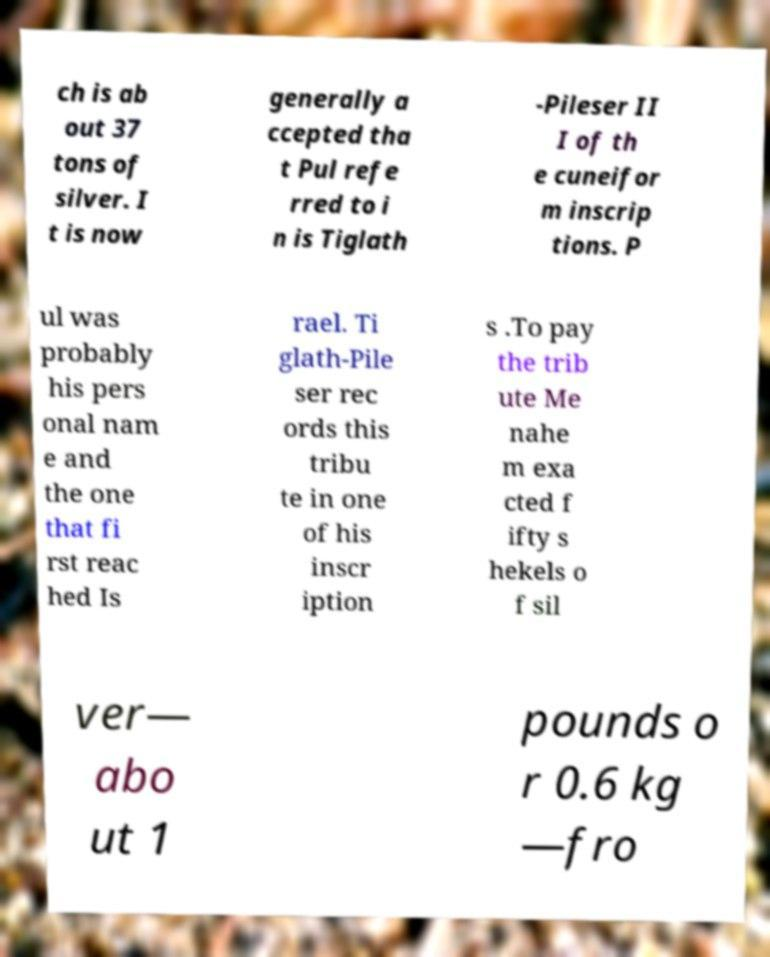There's text embedded in this image that I need extracted. Can you transcribe it verbatim? ch is ab out 37 tons of silver. I t is now generally a ccepted tha t Pul refe rred to i n is Tiglath -Pileser II I of th e cuneifor m inscrip tions. P ul was probably his pers onal nam e and the one that fi rst reac hed Is rael. Ti glath-Pile ser rec ords this tribu te in one of his inscr iption s .To pay the trib ute Me nahe m exa cted f ifty s hekels o f sil ver— abo ut 1 pounds o r 0.6 kg —fro 